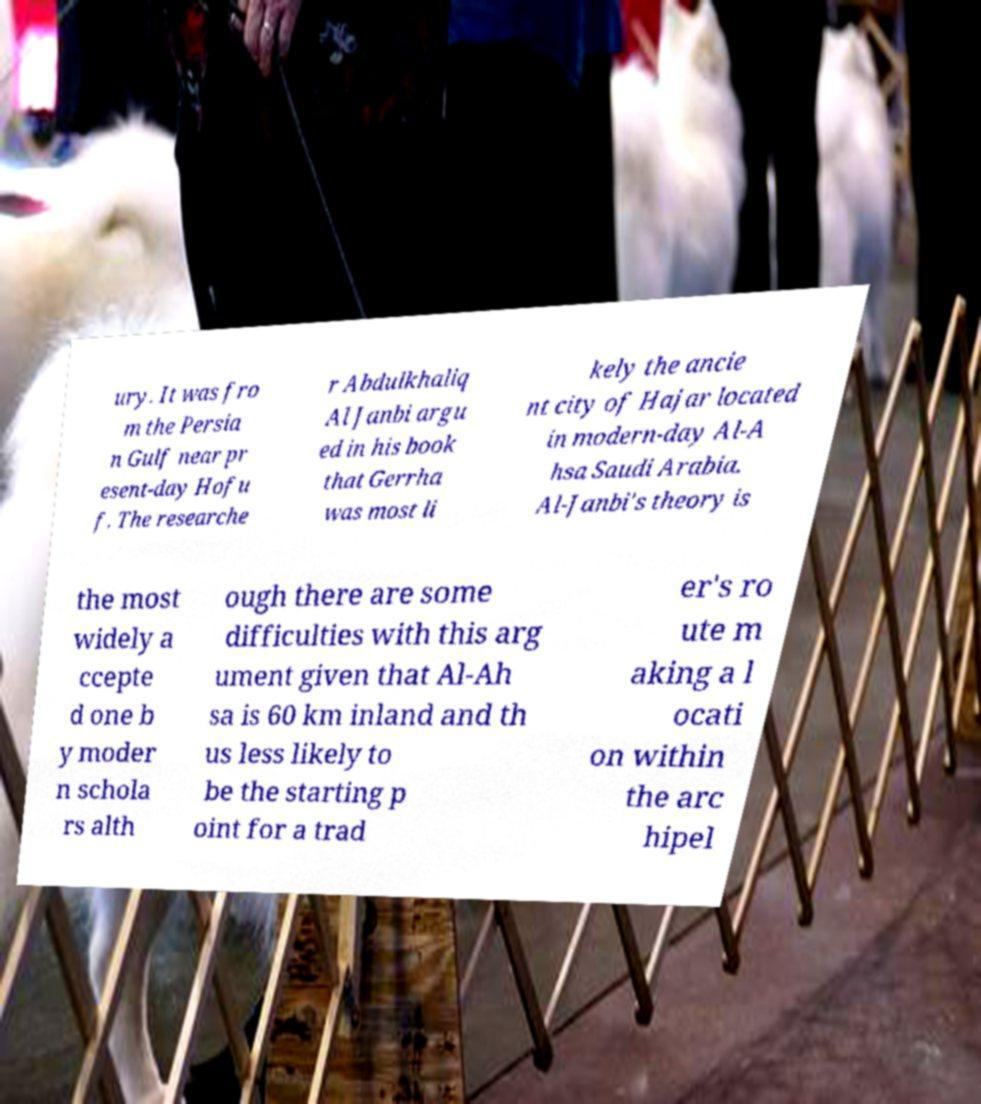There's text embedded in this image that I need extracted. Can you transcribe it verbatim? ury. It was fro m the Persia n Gulf near pr esent-day Hofu f. The researche r Abdulkhaliq Al Janbi argu ed in his book that Gerrha was most li kely the ancie nt city of Hajar located in modern-day Al-A hsa Saudi Arabia. Al-Janbi's theory is the most widely a ccepte d one b y moder n schola rs alth ough there are some difficulties with this arg ument given that Al-Ah sa is 60 km inland and th us less likely to be the starting p oint for a trad er's ro ute m aking a l ocati on within the arc hipel 